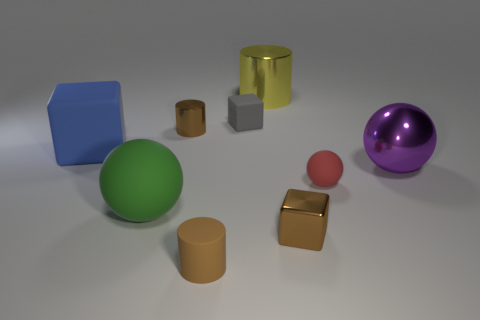Does the cylinder that is to the right of the tiny gray cube have the same material as the brown thing that is left of the small brown rubber object?
Ensure brevity in your answer.  Yes. What is the gray cube made of?
Offer a terse response. Rubber. Is the number of small red objects on the left side of the red thing greater than the number of large metal things?
Your answer should be very brief. No. What number of brown cylinders are behind the matte ball in front of the tiny object right of the small shiny cube?
Your answer should be very brief. 1. What is the material of the block that is right of the big green matte sphere and on the left side of the big cylinder?
Your answer should be very brief. Rubber. What color is the large block?
Offer a very short reply. Blue. Are there more large purple things that are to the left of the tiny red matte object than yellow cylinders in front of the purple ball?
Provide a short and direct response. No. There is a rubber object that is right of the gray object; what color is it?
Ensure brevity in your answer.  Red. Do the rubber block that is right of the blue rubber cube and the object that is in front of the brown block have the same size?
Keep it short and to the point. Yes. How many things are tiny metallic cylinders or big metal objects?
Provide a short and direct response. 3. 